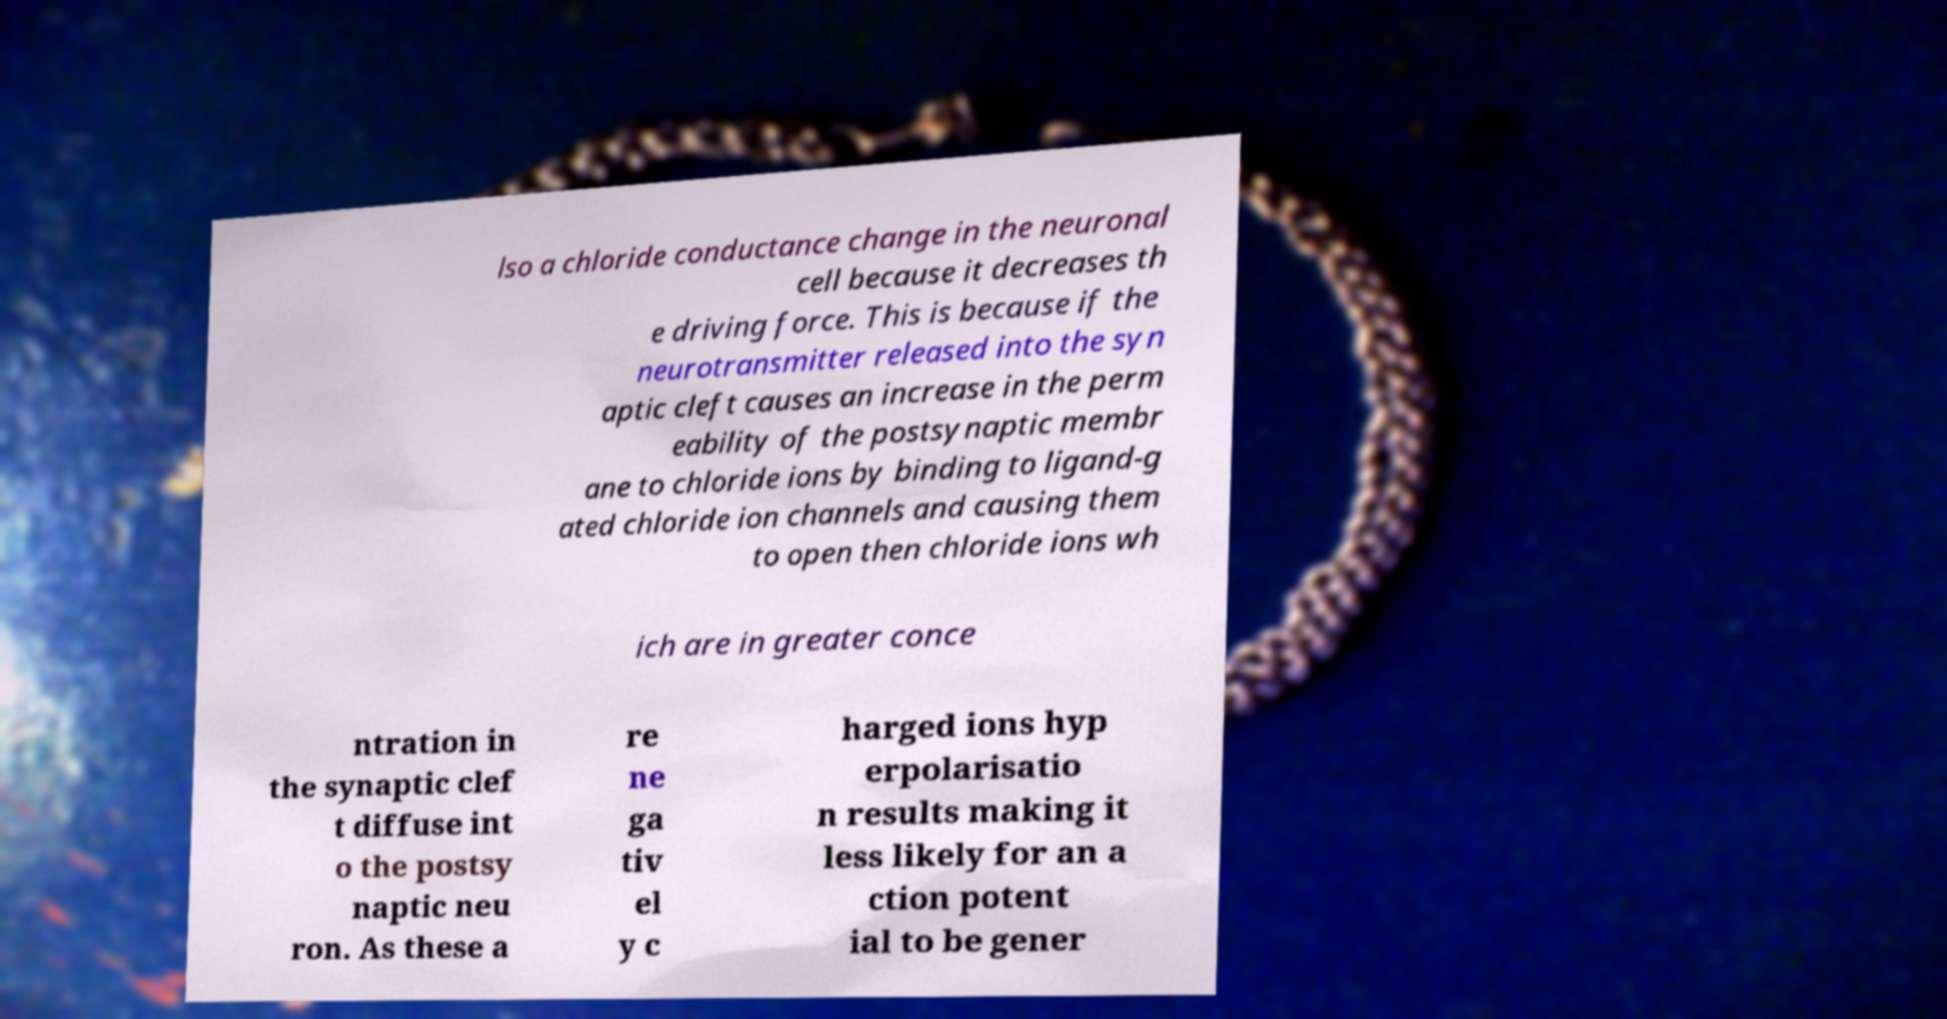For documentation purposes, I need the text within this image transcribed. Could you provide that? lso a chloride conductance change in the neuronal cell because it decreases th e driving force. This is because if the neurotransmitter released into the syn aptic cleft causes an increase in the perm eability of the postsynaptic membr ane to chloride ions by binding to ligand-g ated chloride ion channels and causing them to open then chloride ions wh ich are in greater conce ntration in the synaptic clef t diffuse int o the postsy naptic neu ron. As these a re ne ga tiv el y c harged ions hyp erpolarisatio n results making it less likely for an a ction potent ial to be gener 